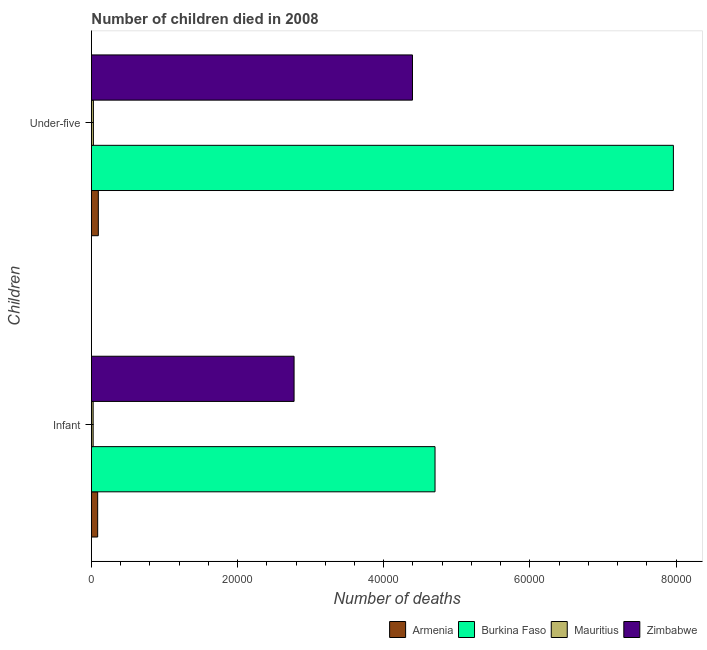How many different coloured bars are there?
Offer a terse response. 4. How many groups of bars are there?
Offer a terse response. 2. Are the number of bars per tick equal to the number of legend labels?
Ensure brevity in your answer.  Yes. How many bars are there on the 2nd tick from the bottom?
Provide a short and direct response. 4. What is the label of the 2nd group of bars from the top?
Provide a succinct answer. Infant. What is the number of under-five deaths in Zimbabwe?
Offer a very short reply. 4.39e+04. Across all countries, what is the maximum number of under-five deaths?
Give a very brief answer. 7.96e+04. Across all countries, what is the minimum number of infant deaths?
Your answer should be very brief. 234. In which country was the number of under-five deaths maximum?
Ensure brevity in your answer.  Burkina Faso. In which country was the number of under-five deaths minimum?
Your answer should be compact. Mauritius. What is the total number of infant deaths in the graph?
Offer a terse response. 7.58e+04. What is the difference between the number of infant deaths in Mauritius and that in Armenia?
Offer a very short reply. -621. What is the difference between the number of infant deaths in Armenia and the number of under-five deaths in Zimbabwe?
Your answer should be very brief. -4.31e+04. What is the average number of infant deaths per country?
Make the answer very short. 1.90e+04. What is the difference between the number of under-five deaths and number of infant deaths in Zimbabwe?
Offer a very short reply. 1.62e+04. What is the ratio of the number of under-five deaths in Armenia to that in Burkina Faso?
Your answer should be very brief. 0.01. What does the 2nd bar from the top in Infant represents?
Keep it short and to the point. Mauritius. What does the 4th bar from the bottom in Under-five represents?
Offer a very short reply. Zimbabwe. How many bars are there?
Your answer should be compact. 8. What is the difference between two consecutive major ticks on the X-axis?
Ensure brevity in your answer.  2.00e+04. Are the values on the major ticks of X-axis written in scientific E-notation?
Your response must be concise. No. Does the graph contain grids?
Keep it short and to the point. No. What is the title of the graph?
Your response must be concise. Number of children died in 2008. What is the label or title of the X-axis?
Your response must be concise. Number of deaths. What is the label or title of the Y-axis?
Keep it short and to the point. Children. What is the Number of deaths in Armenia in Infant?
Your answer should be compact. 855. What is the Number of deaths in Burkina Faso in Infant?
Make the answer very short. 4.70e+04. What is the Number of deaths in Mauritius in Infant?
Provide a short and direct response. 234. What is the Number of deaths in Zimbabwe in Infant?
Keep it short and to the point. 2.77e+04. What is the Number of deaths in Armenia in Under-five?
Your response must be concise. 944. What is the Number of deaths in Burkina Faso in Under-five?
Offer a terse response. 7.96e+04. What is the Number of deaths of Mauritius in Under-five?
Your response must be concise. 269. What is the Number of deaths of Zimbabwe in Under-five?
Offer a very short reply. 4.39e+04. Across all Children, what is the maximum Number of deaths of Armenia?
Ensure brevity in your answer.  944. Across all Children, what is the maximum Number of deaths in Burkina Faso?
Make the answer very short. 7.96e+04. Across all Children, what is the maximum Number of deaths of Mauritius?
Offer a very short reply. 269. Across all Children, what is the maximum Number of deaths in Zimbabwe?
Make the answer very short. 4.39e+04. Across all Children, what is the minimum Number of deaths in Armenia?
Your answer should be compact. 855. Across all Children, what is the minimum Number of deaths in Burkina Faso?
Make the answer very short. 4.70e+04. Across all Children, what is the minimum Number of deaths of Mauritius?
Your response must be concise. 234. Across all Children, what is the minimum Number of deaths in Zimbabwe?
Your answer should be very brief. 2.77e+04. What is the total Number of deaths in Armenia in the graph?
Make the answer very short. 1799. What is the total Number of deaths in Burkina Faso in the graph?
Provide a short and direct response. 1.27e+05. What is the total Number of deaths of Mauritius in the graph?
Give a very brief answer. 503. What is the total Number of deaths in Zimbabwe in the graph?
Keep it short and to the point. 7.17e+04. What is the difference between the Number of deaths in Armenia in Infant and that in Under-five?
Make the answer very short. -89. What is the difference between the Number of deaths in Burkina Faso in Infant and that in Under-five?
Offer a terse response. -3.26e+04. What is the difference between the Number of deaths of Mauritius in Infant and that in Under-five?
Your answer should be compact. -35. What is the difference between the Number of deaths in Zimbabwe in Infant and that in Under-five?
Provide a short and direct response. -1.62e+04. What is the difference between the Number of deaths in Armenia in Infant and the Number of deaths in Burkina Faso in Under-five?
Ensure brevity in your answer.  -7.88e+04. What is the difference between the Number of deaths in Armenia in Infant and the Number of deaths in Mauritius in Under-five?
Your answer should be very brief. 586. What is the difference between the Number of deaths of Armenia in Infant and the Number of deaths of Zimbabwe in Under-five?
Keep it short and to the point. -4.31e+04. What is the difference between the Number of deaths of Burkina Faso in Infant and the Number of deaths of Mauritius in Under-five?
Your answer should be compact. 4.68e+04. What is the difference between the Number of deaths of Burkina Faso in Infant and the Number of deaths of Zimbabwe in Under-five?
Make the answer very short. 3085. What is the difference between the Number of deaths of Mauritius in Infant and the Number of deaths of Zimbabwe in Under-five?
Offer a terse response. -4.37e+04. What is the average Number of deaths of Armenia per Children?
Offer a very short reply. 899.5. What is the average Number of deaths in Burkina Faso per Children?
Give a very brief answer. 6.33e+04. What is the average Number of deaths in Mauritius per Children?
Ensure brevity in your answer.  251.5. What is the average Number of deaths in Zimbabwe per Children?
Your response must be concise. 3.58e+04. What is the difference between the Number of deaths of Armenia and Number of deaths of Burkina Faso in Infant?
Provide a succinct answer. -4.62e+04. What is the difference between the Number of deaths of Armenia and Number of deaths of Mauritius in Infant?
Give a very brief answer. 621. What is the difference between the Number of deaths in Armenia and Number of deaths in Zimbabwe in Infant?
Give a very brief answer. -2.69e+04. What is the difference between the Number of deaths in Burkina Faso and Number of deaths in Mauritius in Infant?
Make the answer very short. 4.68e+04. What is the difference between the Number of deaths in Burkina Faso and Number of deaths in Zimbabwe in Infant?
Keep it short and to the point. 1.93e+04. What is the difference between the Number of deaths of Mauritius and Number of deaths of Zimbabwe in Infant?
Ensure brevity in your answer.  -2.75e+04. What is the difference between the Number of deaths in Armenia and Number of deaths in Burkina Faso in Under-five?
Keep it short and to the point. -7.87e+04. What is the difference between the Number of deaths in Armenia and Number of deaths in Mauritius in Under-five?
Make the answer very short. 675. What is the difference between the Number of deaths in Armenia and Number of deaths in Zimbabwe in Under-five?
Give a very brief answer. -4.30e+04. What is the difference between the Number of deaths of Burkina Faso and Number of deaths of Mauritius in Under-five?
Give a very brief answer. 7.94e+04. What is the difference between the Number of deaths in Burkina Faso and Number of deaths in Zimbabwe in Under-five?
Give a very brief answer. 3.57e+04. What is the difference between the Number of deaths in Mauritius and Number of deaths in Zimbabwe in Under-five?
Make the answer very short. -4.37e+04. What is the ratio of the Number of deaths of Armenia in Infant to that in Under-five?
Make the answer very short. 0.91. What is the ratio of the Number of deaths in Burkina Faso in Infant to that in Under-five?
Give a very brief answer. 0.59. What is the ratio of the Number of deaths in Mauritius in Infant to that in Under-five?
Provide a short and direct response. 0.87. What is the ratio of the Number of deaths in Zimbabwe in Infant to that in Under-five?
Your answer should be compact. 0.63. What is the difference between the highest and the second highest Number of deaths of Armenia?
Provide a short and direct response. 89. What is the difference between the highest and the second highest Number of deaths in Burkina Faso?
Offer a very short reply. 3.26e+04. What is the difference between the highest and the second highest Number of deaths in Mauritius?
Give a very brief answer. 35. What is the difference between the highest and the second highest Number of deaths in Zimbabwe?
Your answer should be very brief. 1.62e+04. What is the difference between the highest and the lowest Number of deaths in Armenia?
Offer a very short reply. 89. What is the difference between the highest and the lowest Number of deaths in Burkina Faso?
Give a very brief answer. 3.26e+04. What is the difference between the highest and the lowest Number of deaths in Zimbabwe?
Offer a very short reply. 1.62e+04. 